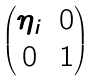Convert formula to latex. <formula><loc_0><loc_0><loc_500><loc_500>\begin{pmatrix} \eta _ { i } & 0 \\ 0 & 1 \end{pmatrix}</formula> 